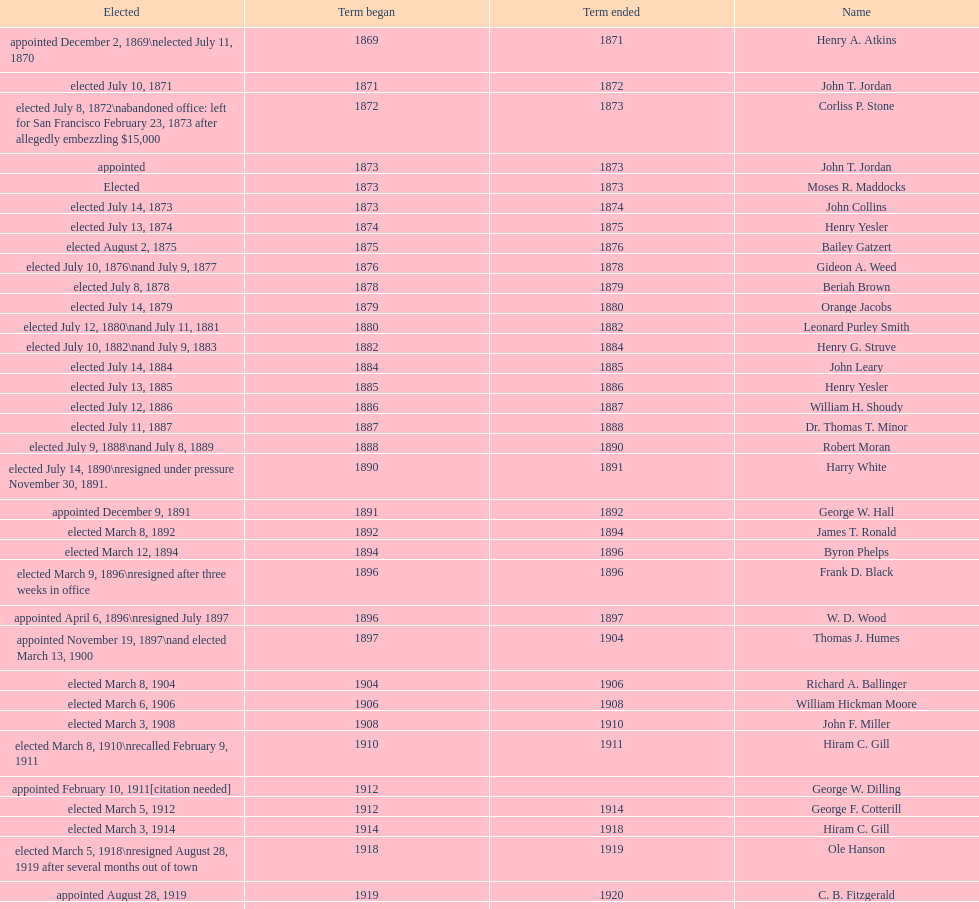Who was mayor of seattle, washington before being appointed to department of transportation during the nixon administration? James d'Orma Braman. 